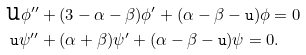<formula> <loc_0><loc_0><loc_500><loc_500>\text {\tt u} \phi ^ { \prime \prime } & + ( 3 - \alpha - \beta ) \phi ^ { \prime } + ( \alpha - \beta - \text {\tt u} ) \phi = 0 \\ \text {\tt u} \psi ^ { \prime \prime } & + ( \alpha + \beta ) \psi ^ { \prime } + ( \alpha - \beta - \text {\tt u} ) \psi = 0 . \\</formula> 